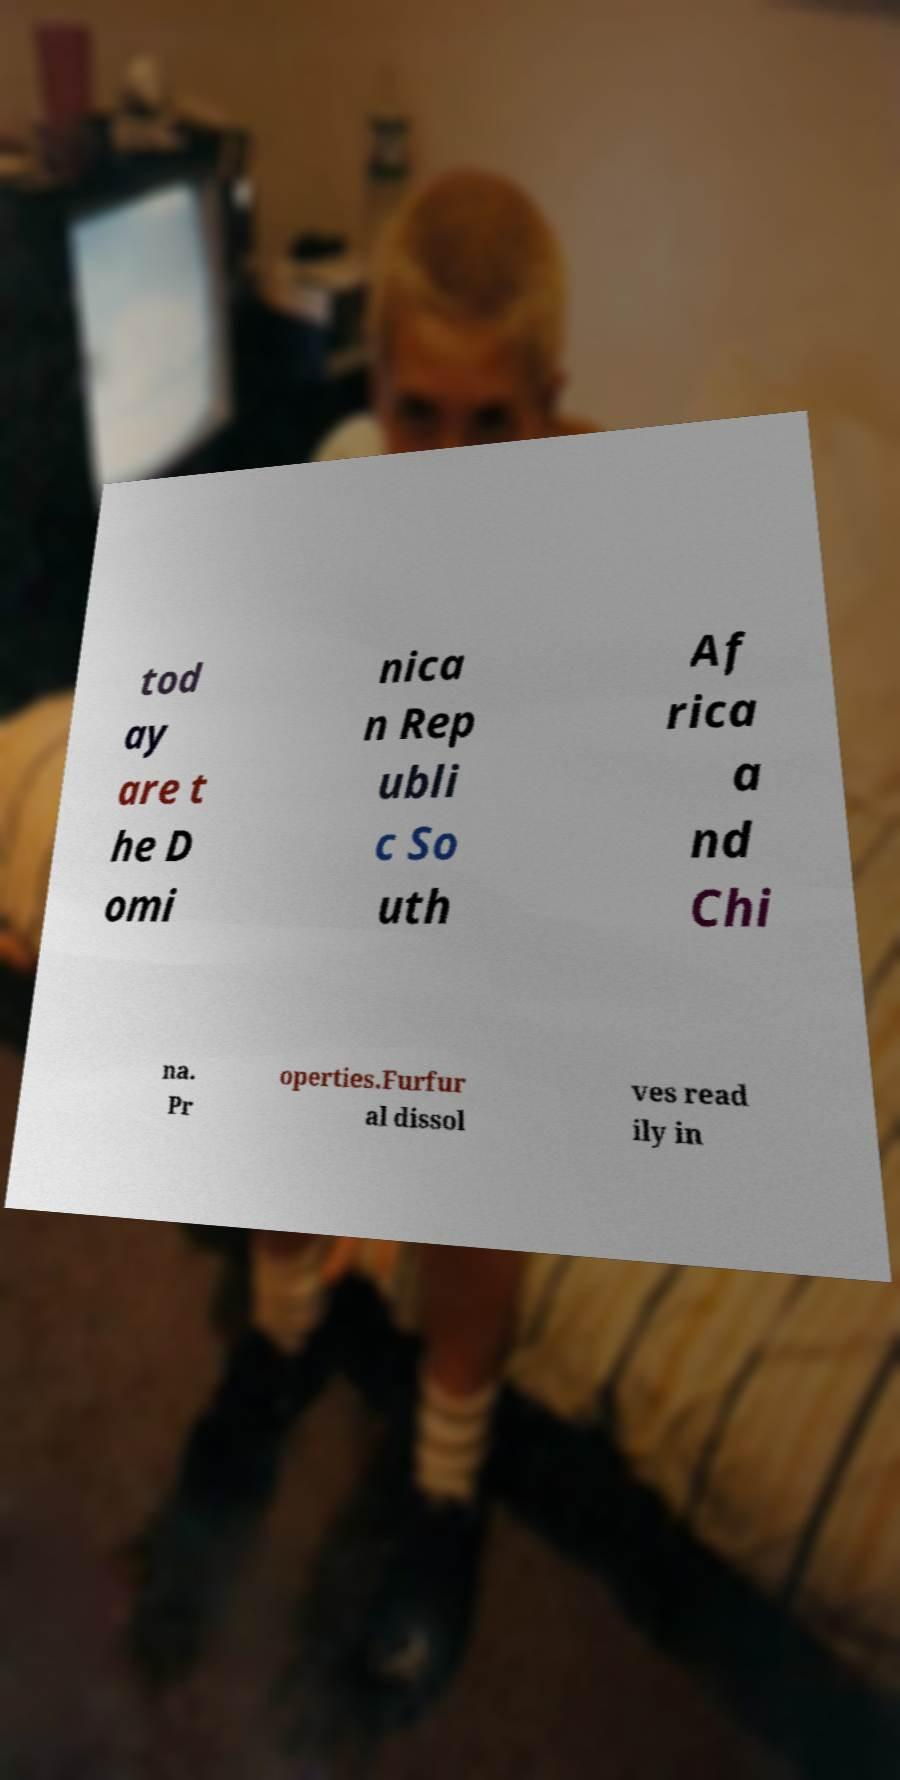I need the written content from this picture converted into text. Can you do that? tod ay are t he D omi nica n Rep ubli c So uth Af rica a nd Chi na. Pr operties.Furfur al dissol ves read ily in 